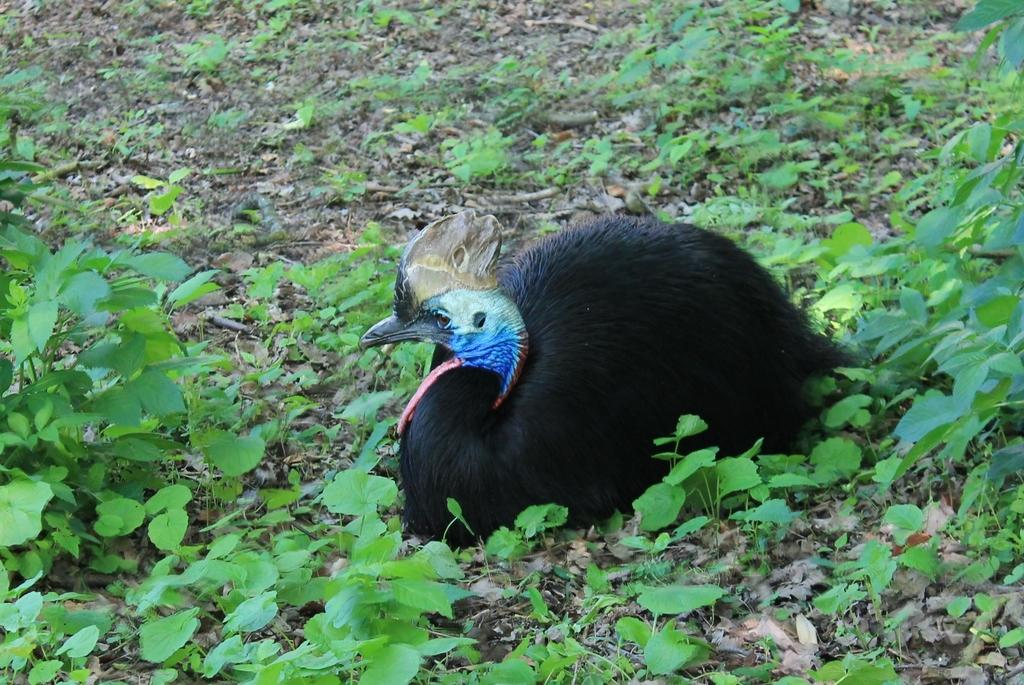What type of living organisms can be seen in the image? Plants and a bird are visible in the image. Where is the bird located in the image? The bird is sitting on the ground. Can you describe the bird's position in relation to the plants? The bird is sitting on the ground among the plants. What type of sugar is the bird using to sweeten its nest in the image? There is no nest or sugar present in the image; the bird is simply sitting on the ground among the plants. 